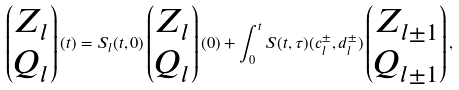<formula> <loc_0><loc_0><loc_500><loc_500>\begin{pmatrix} Z _ { l } \\ Q _ { l } \end{pmatrix} ( t ) = S _ { l } ( t , 0 ) \begin{pmatrix} Z _ { l } \\ Q _ { l } \end{pmatrix} ( 0 ) + \int _ { 0 } ^ { t } S ( t , \tau ) ( c _ { l } ^ { \pm } , d _ { l } ^ { \pm } ) \begin{pmatrix} Z _ { l \pm 1 } \\ Q _ { l \pm 1 } \end{pmatrix} ,</formula> 